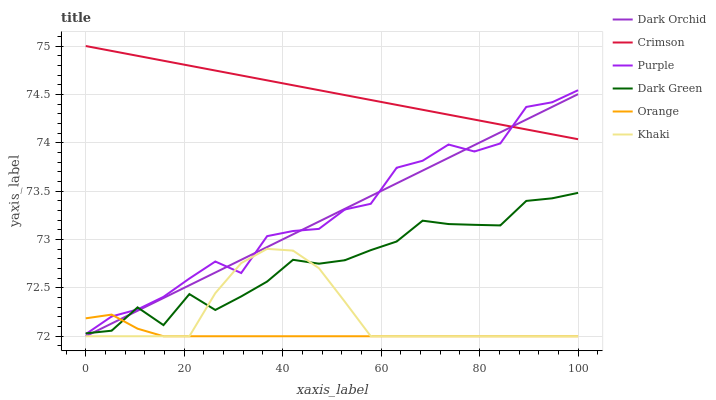Does Purple have the minimum area under the curve?
Answer yes or no. No. Does Purple have the maximum area under the curve?
Answer yes or no. No. Is Dark Orchid the smoothest?
Answer yes or no. No. Is Dark Orchid the roughest?
Answer yes or no. No. Does Purple have the lowest value?
Answer yes or no. No. Does Purple have the highest value?
Answer yes or no. No. Is Orange less than Crimson?
Answer yes or no. Yes. Is Crimson greater than Dark Green?
Answer yes or no. Yes. Does Orange intersect Crimson?
Answer yes or no. No. 